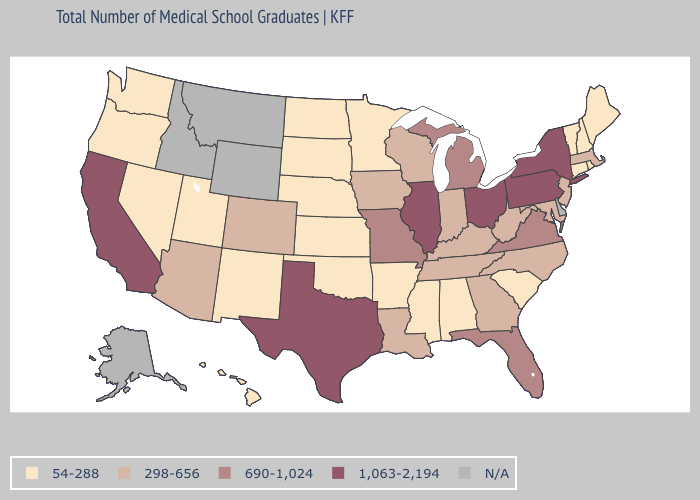How many symbols are there in the legend?
Give a very brief answer. 5. Name the states that have a value in the range N/A?
Concise answer only. Alaska, Delaware, Idaho, Montana, Wyoming. What is the value of South Carolina?
Answer briefly. 54-288. What is the value of Nevada?
Give a very brief answer. 54-288. Which states have the highest value in the USA?
Write a very short answer. California, Illinois, New York, Ohio, Pennsylvania, Texas. Name the states that have a value in the range 690-1,024?
Give a very brief answer. Florida, Michigan, Missouri, Virginia. Name the states that have a value in the range 298-656?
Concise answer only. Arizona, Colorado, Georgia, Indiana, Iowa, Kentucky, Louisiana, Maryland, Massachusetts, New Jersey, North Carolina, Tennessee, West Virginia, Wisconsin. What is the value of Rhode Island?
Short answer required. 54-288. Name the states that have a value in the range 1,063-2,194?
Short answer required. California, Illinois, New York, Ohio, Pennsylvania, Texas. What is the value of Illinois?
Concise answer only. 1,063-2,194. What is the value of Nebraska?
Concise answer only. 54-288. What is the highest value in the USA?
Keep it brief. 1,063-2,194. Does the first symbol in the legend represent the smallest category?
Be succinct. Yes. 